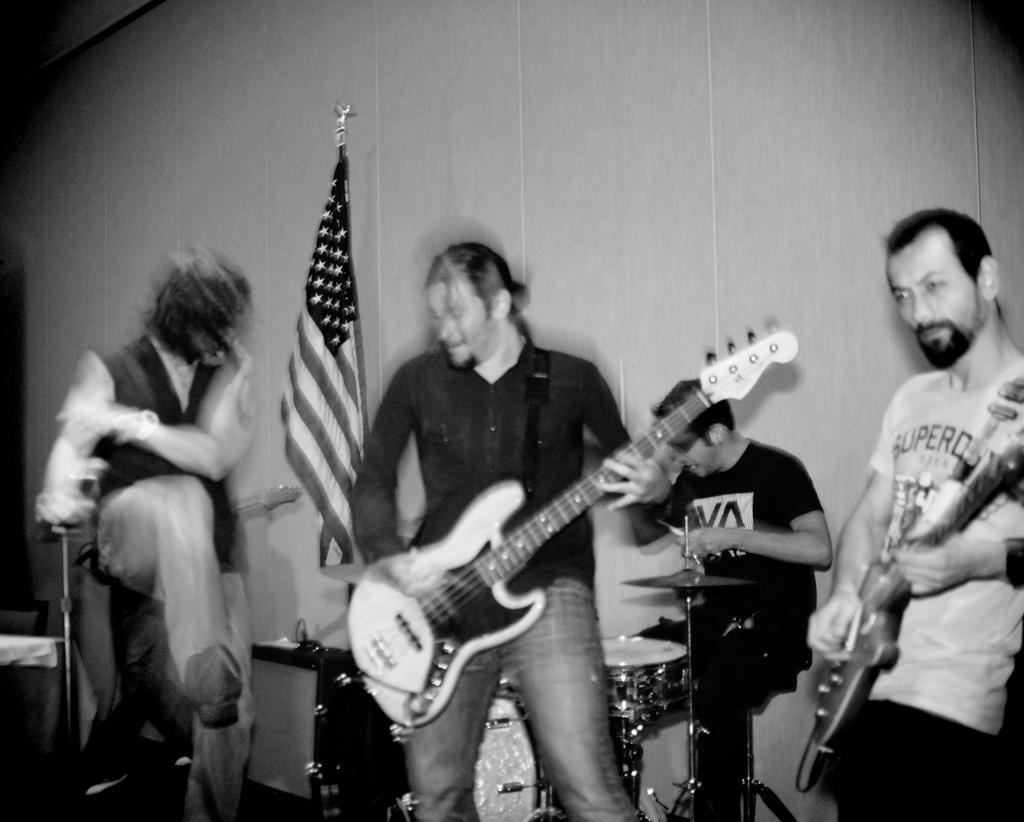How many people are in the image? There are four people in the image. What are the two people at the front doing? They are playing guitar. What is the third person at the front doing? The third person is playing drums. Can you describe the object on the left side of the image? There is a flag on the left side of the image. What type of cloud can be seen in the park in the image? There is no park or cloud present in the image. 